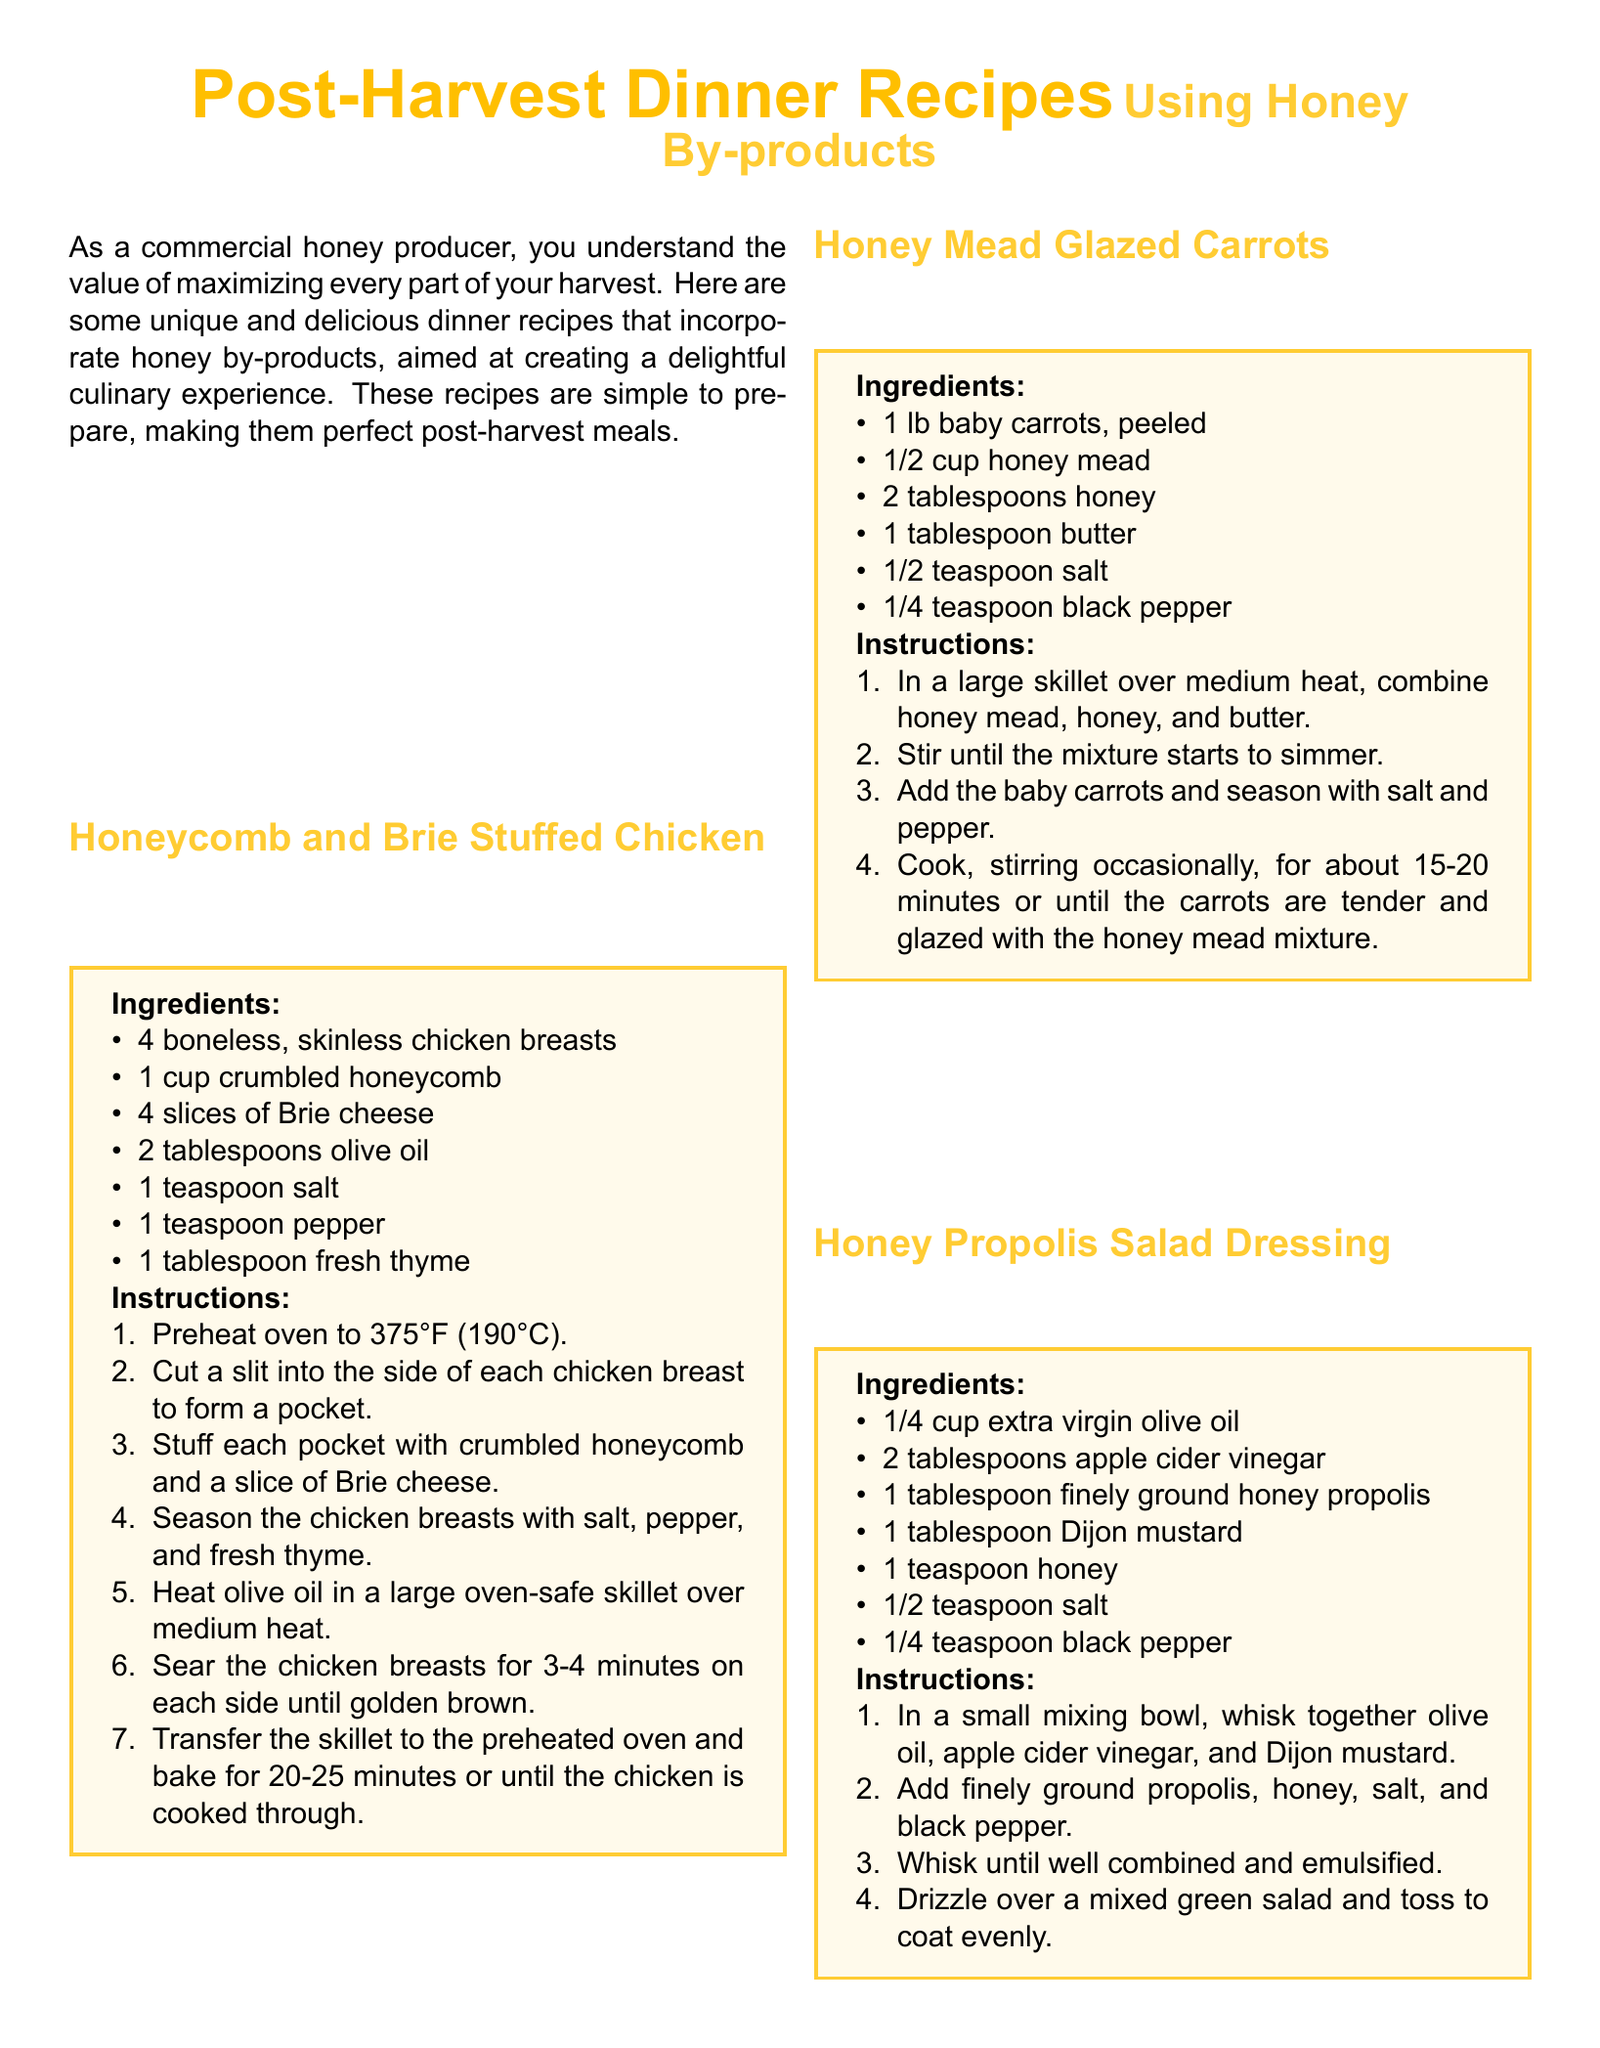What is the first recipe listed in the document? The first recipe in the document is titled "Honeycomb and Brie Stuffed Chicken."
Answer: Honeycomb and Brie Stuffed Chicken How many boneless chicken breasts are required for the first recipe? The first recipe requires 4 boneless, skinless chicken breasts.
Answer: 4 What ingredient is used to glaze the carrots in the second recipe? The second recipe uses honey mead and honey to glaze the carrots.
Answer: honey mead What is the cooking temperature for the salmon dish? The salmon dish is baked at a temperature of 400°F (200°C).
Answer: 400°F (200°C) Which dressing ingredient is combined with honey in the salad recipe? The honey propolis is combined with honey in the salad dressing recipe.
Answer: honey propolis How many total ingredients are listed for the Honey Mead Glazed Carrots? There are 6 ingredients listed for the Honey Mead Glazed Carrots recipe.
Answer: 6 What is the primary purpose of the document? The document provides unique and delicious dinner recipes using honey by-products.
Answer: dinner recipes using honey by-products Which recipe involves using bread crumbs? The recipe for "Bee Pollen Crusted Salmon" involves using breadcrumbs.
Answer: Bee Pollen Crusted Salmon 